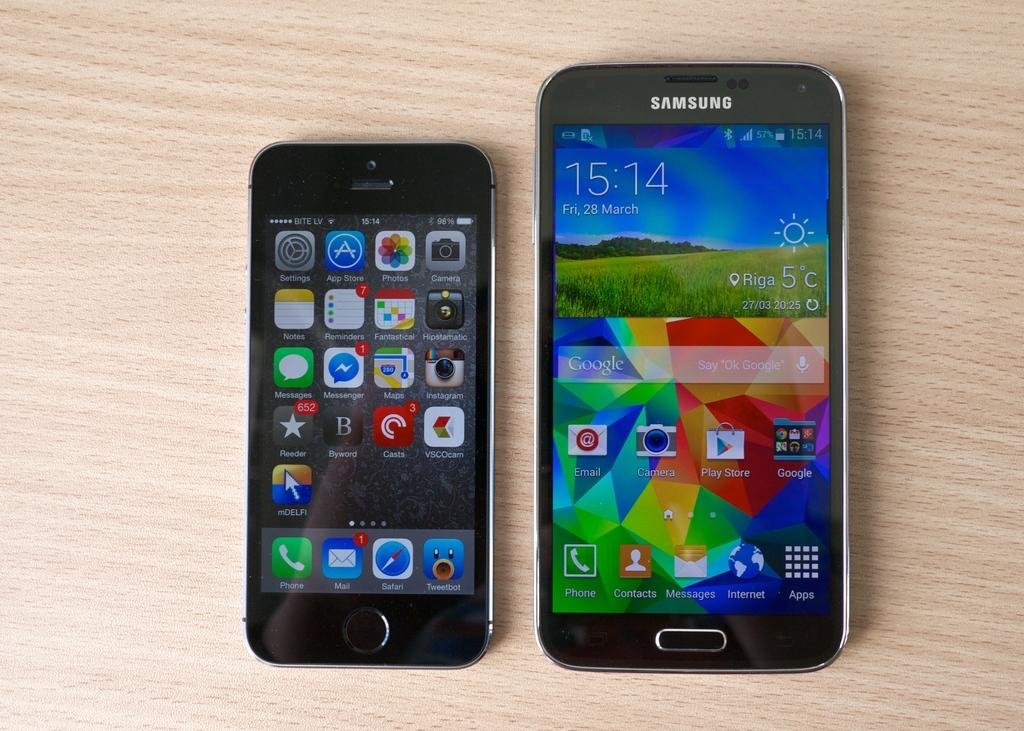<image>
Give a short and clear explanation of the subsequent image. A Samsung phone sits next to an iPhone on a wooden table. 